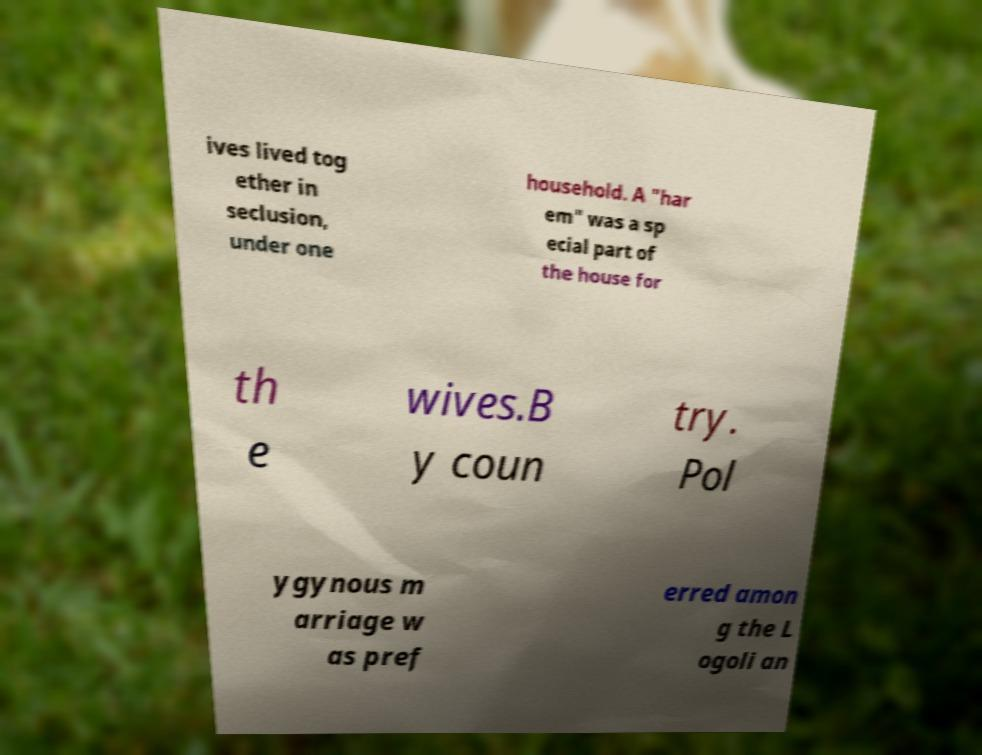Can you accurately transcribe the text from the provided image for me? ives lived tog ether in seclusion, under one household. A "har em" was a sp ecial part of the house for th e wives.B y coun try. Pol ygynous m arriage w as pref erred amon g the L ogoli an 